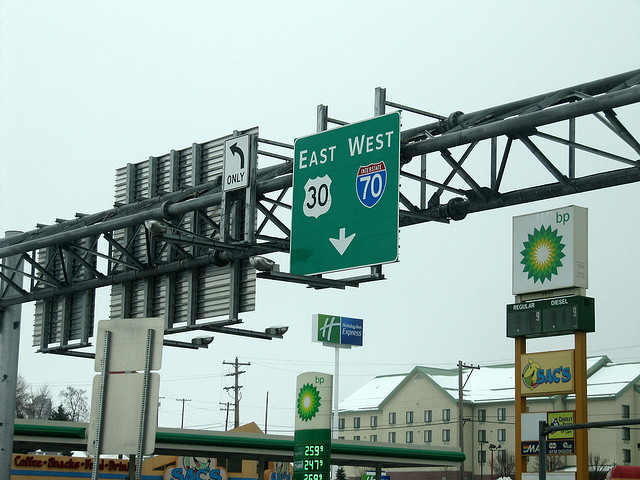<image>Which direction does one go for Wasatch National Forest? It is ambiguous which direction one should go for Wasatch National Forest. The answers are varied. Which direction does one go for Wasatch National Forest? I don't know the direction to go for Wasatch National Forest. It can be either left, east, north, west, or straight. 